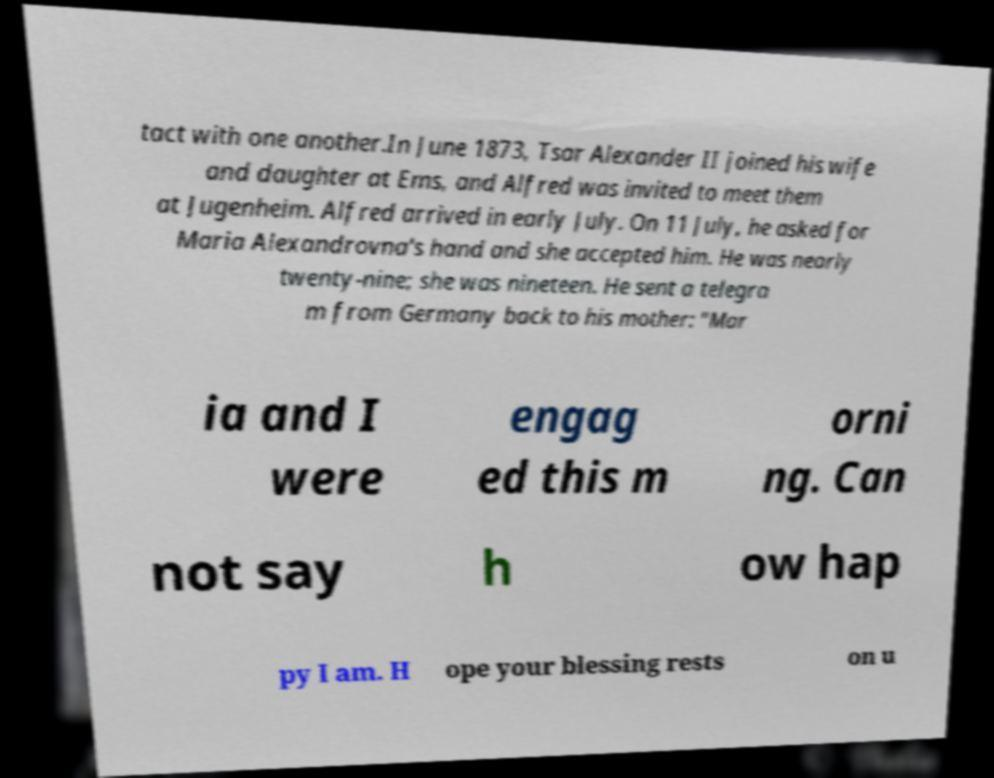I need the written content from this picture converted into text. Can you do that? tact with one another.In June 1873, Tsar Alexander II joined his wife and daughter at Ems, and Alfred was invited to meet them at Jugenheim. Alfred arrived in early July. On 11 July, he asked for Maria Alexandrovna's hand and she accepted him. He was nearly twenty-nine; she was nineteen. He sent a telegra m from Germany back to his mother: "Mar ia and I were engag ed this m orni ng. Can not say h ow hap py I am. H ope your blessing rests on u 